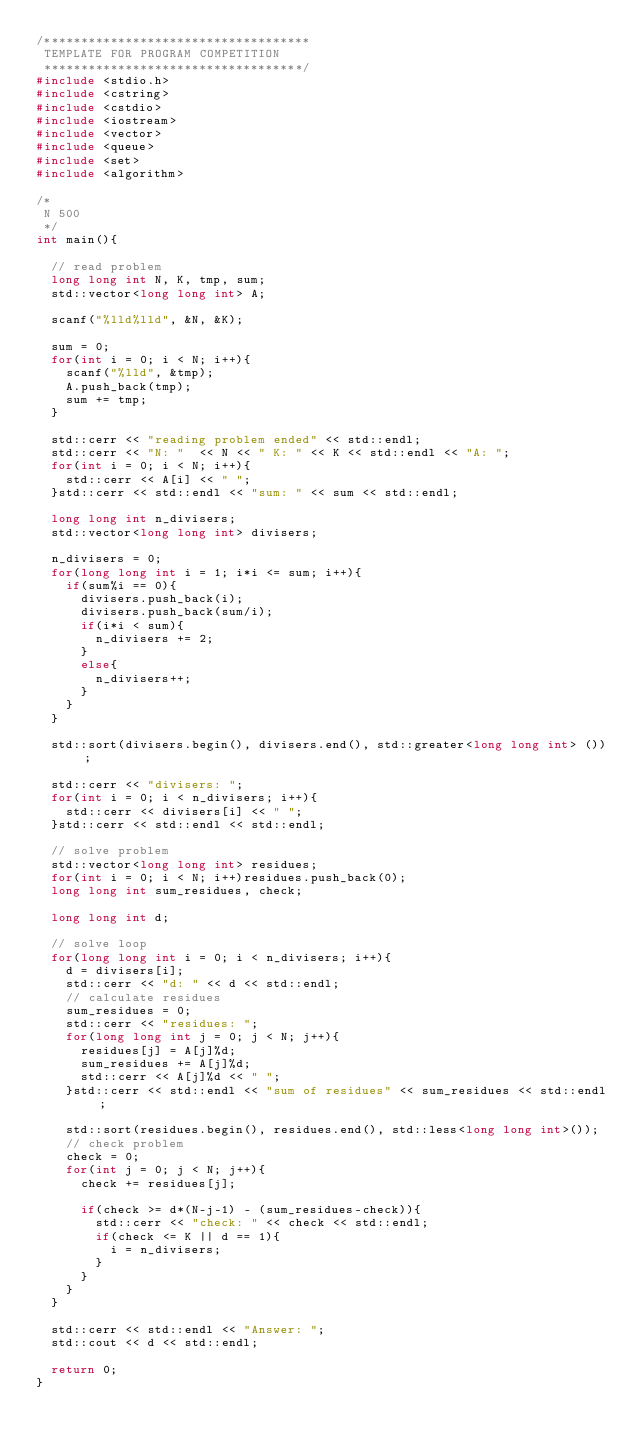<code> <loc_0><loc_0><loc_500><loc_500><_C++_>/************************************
 TEMPLATE FOR PROGRAM COMPETITION
 ***********************************/
#include <stdio.h>
#include <cstring>
#include <cstdio>
#include <iostream>
#include <vector>
#include <queue>
#include <set>
#include <algorithm>

/*
 N 500
 */
int main(){
  
  // read problem
  long long int N, K, tmp, sum;
  std::vector<long long int> A;

  scanf("%lld%lld", &N, &K);
  
  sum = 0;
  for(int i = 0; i < N; i++){
    scanf("%lld", &tmp);
    A.push_back(tmp);
    sum += tmp;
  }
  
  std::cerr << "reading problem ended" << std::endl;
  std::cerr << "N: "  << N << " K: " << K << std::endl << "A: ";
  for(int i = 0; i < N; i++){
    std::cerr << A[i] << " ";
  }std::cerr << std::endl << "sum: " << sum << std::endl;
 
  long long int n_divisers;
  std::vector<long long int> divisers;
  
  n_divisers = 0;
  for(long long int i = 1; i*i <= sum; i++){
    if(sum%i == 0){
      divisers.push_back(i);
      divisers.push_back(sum/i);
      if(i*i < sum){
        n_divisers += 2;
      }
      else{
        n_divisers++;
      }
    }
  }
  
  std::sort(divisers.begin(), divisers.end(), std::greater<long long int> ());
  
  std::cerr << "divisers: ";
  for(int i = 0; i < n_divisers; i++){
    std::cerr << divisers[i] << " ";
  }std::cerr << std::endl << std::endl;
  
  // solve problem
  std::vector<long long int> residues;
  for(int i = 0; i < N; i++)residues.push_back(0);
  long long int sum_residues, check;
  
  long long int d;
  
  // solve loop
  for(long long int i = 0; i < n_divisers; i++){
    d = divisers[i];
    std::cerr << "d: " << d << std::endl;
    // calculate residues
    sum_residues = 0;
    std::cerr << "residues: ";
    for(long long int j = 0; j < N; j++){
      residues[j] = A[j]%d;
      sum_residues += A[j]%d;
      std::cerr << A[j]%d << " ";
    }std::cerr << std::endl << "sum of residues" << sum_residues << std::endl;
    
    std::sort(residues.begin(), residues.end(), std::less<long long int>());
    // check problem
    check = 0;
    for(int j = 0; j < N; j++){
      check += residues[j];

      if(check >= d*(N-j-1) - (sum_residues-check)){
        std::cerr << "check: " << check << std::endl;
        if(check <= K || d == 1){
          i = n_divisers;
        }
      }
    }
  }
  
  std::cerr << std::endl << "Answer: ";
  std::cout << d << std::endl;
  
  return 0;
}
</code> 